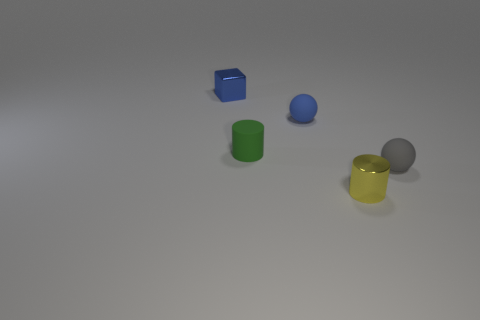Do the yellow metallic object and the gray matte ball have the same size?
Make the answer very short. Yes. How many things are big purple rubber objects or metal objects right of the blue shiny block?
Keep it short and to the point. 1. Are there fewer tiny shiny cubes that are in front of the small green rubber object than small blue rubber spheres that are in front of the gray rubber ball?
Give a very brief answer. No. How many other objects are there of the same material as the tiny yellow cylinder?
Your answer should be compact. 1. There is a tiny sphere that is on the left side of the small yellow metal object; is it the same color as the tiny block?
Ensure brevity in your answer.  Yes. There is a tiny shiny thing that is in front of the blue metal thing; are there any small matte spheres that are in front of it?
Provide a succinct answer. No. There is a object that is both behind the tiny green matte object and in front of the tiny block; what is its material?
Provide a short and direct response. Rubber. The yellow thing that is the same material as the tiny blue cube is what shape?
Make the answer very short. Cylinder. Is there anything else that is the same shape as the small green matte object?
Offer a very short reply. Yes. Do the cylinder that is to the left of the blue rubber sphere and the tiny yellow thing have the same material?
Ensure brevity in your answer.  No. 